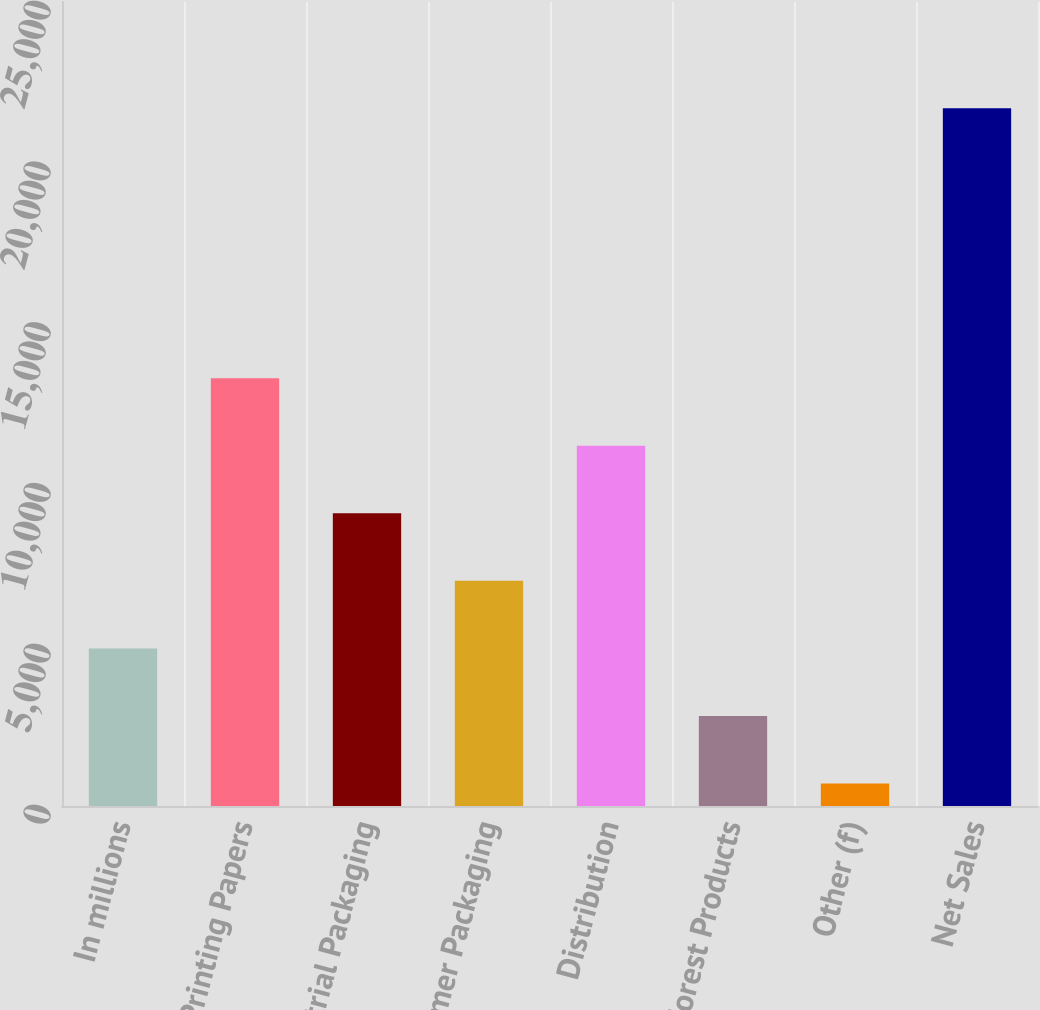<chart> <loc_0><loc_0><loc_500><loc_500><bar_chart><fcel>In millions<fcel>Printing Papers<fcel>Industrial Packaging<fcel>Consumer Packaging<fcel>Distribution<fcel>Forest Products<fcel>Other (f)<fcel>Net Sales<nl><fcel>4900.8<fcel>13300.4<fcel>9100.6<fcel>7000.7<fcel>11200.5<fcel>2800.9<fcel>701<fcel>21700<nl></chart> 